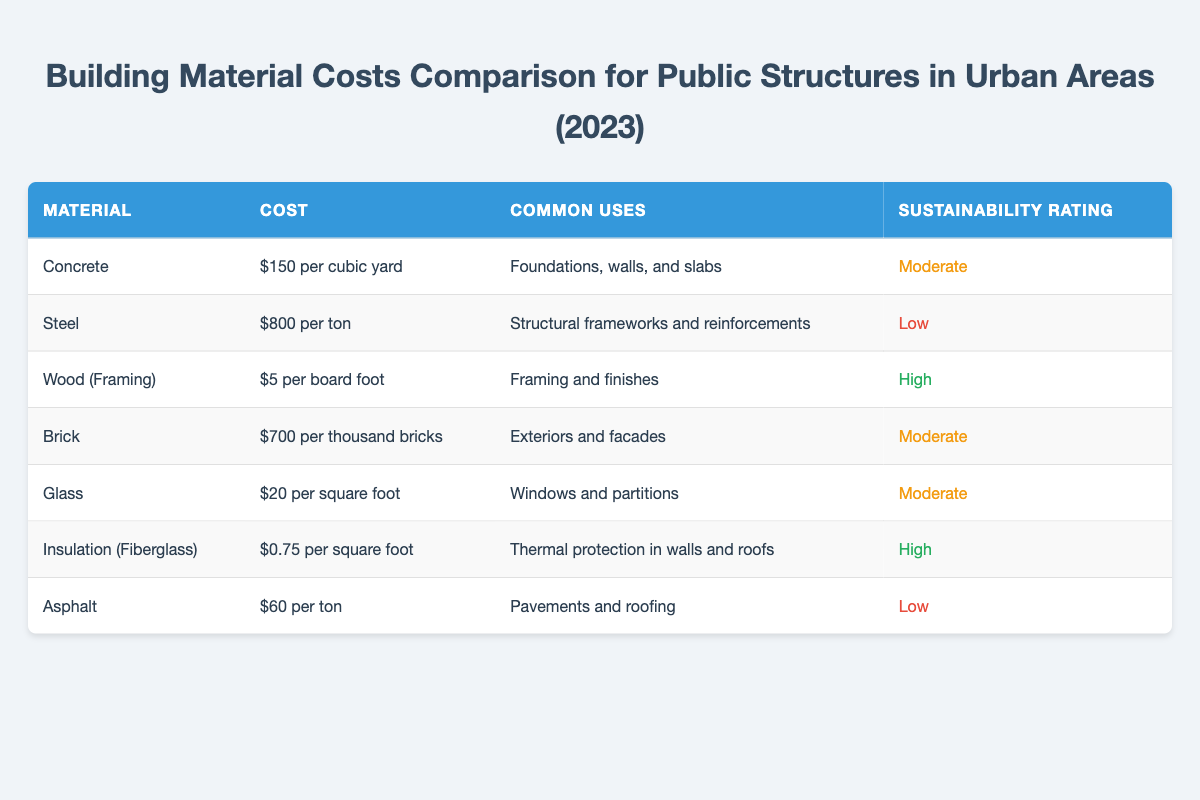What is the cost of concrete per cubic yard? The table lists that the cost of concrete is $150 per cubic yard.
Answer: $150 Which building material has the highest sustainability rating? The table shows that both Wood (Framing) and Insulation (Fiberglass) have a sustainability rating classified as high.
Answer: Wood (Framing) and Insulation (Fiberglass) What are the common uses for brick? According to the table, brick is commonly used for exteriors and facades.
Answer: Exteriors and facades Is the cost of insulation higher than the cost of asphalt? The table shows that insulation costs $0.75 per square foot, while asphalt costs $60 per ton. Since square foot and ton are different units of measure, direct comparison is not applicable. However, there is no implication that insulation costs more than asphalt.
Answer: No What is the total cost of 1 ton of steel compared to 1 ton of asphalt? The table indicates that steel costs $800 per ton and asphalt costs $60 per ton. Summing these costs gives $800 + $60 = $860, which means steel is much more expensive than asphalt.
Answer: Steel is more expensive, total is $860 If we consider a building that requires 1000 bricks, what would be the cost? The cost of brick is $700 per thousand bricks from the table. Therefore, the cost for 1000 bricks would be $700.
Answer: $700 What is the average cost per unit of the materials listed in the table? To find the average cost, calculate the total cost for the various materials and divide by the number of different materials. The total costs are $150, $800, $5, $700, $20, $0.75, and $60. Therefore, total = $150 + $800 + $5 + $700 + $20 + $0.75 + $60 = $1735. There are 7 materials, so the average cost is $1735/7 = $247.86.
Answer: $247.86 Does any material listed have both a low sustainability rating and a low cost? The table indicates that steel has a low sustainability rating, but it costs $800 per ton, while asphalt has both a low sustainability rating and a lower cost of $60 per ton. Therefore, the answer is yes.
Answer: Yes, asphalt What is the difference in cost between wood (framing) and glass? The cost of wood (framing) is $5 per board foot and the cost of glass is $20 per square foot. Since these different units (board foot vs square foot) do not allow direct comparison, the difference can be represented in their respective units with glass being more expensive by $15.
Answer: Glass is $15 more expensive 